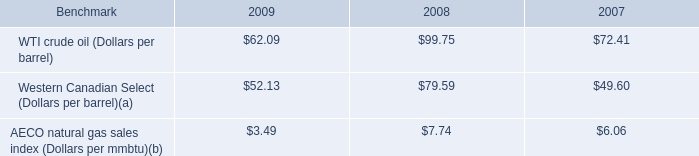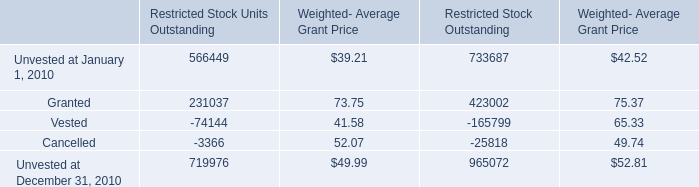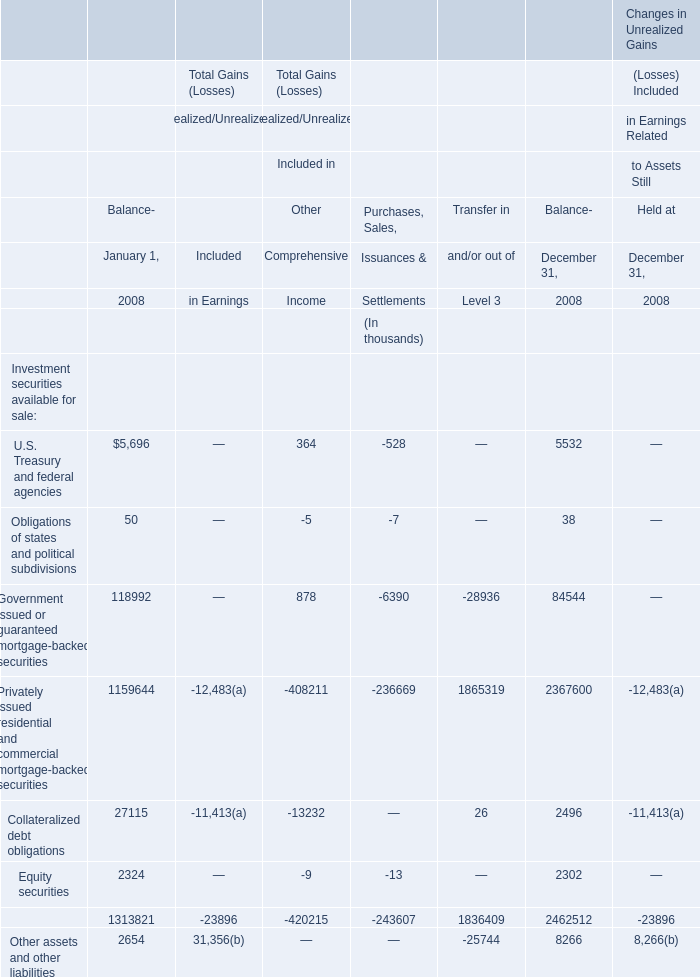In what sections is Obligations of states and political subdivisions greater than 0? 
Answer: Balance- January 1 2008,Balance-December 31 2008. 